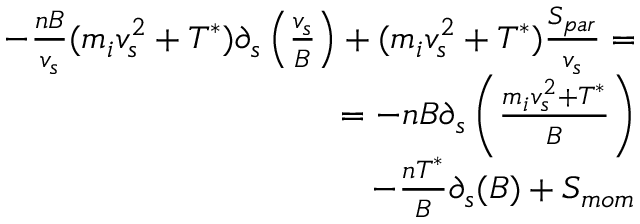<formula> <loc_0><loc_0><loc_500><loc_500>\begin{array} { r } { - \frac { n B } { v _ { s } } ( m _ { i } v _ { s } ^ { 2 } + T ^ { * } ) \partial _ { s } \left ( \frac { v _ { s } } { B } \right ) + ( m _ { i } v _ { s } ^ { 2 } + T ^ { * } ) \frac { S _ { p a r } } { v _ { s } } = } \\ { = - n B \partial _ { s } \left ( \frac { m _ { i } v _ { s } ^ { 2 } + T ^ { * } } { B } \right ) } \\ { - \frac { n T ^ { * } } { B } \partial _ { s } ( B ) + S _ { m o m } } \end{array}</formula> 